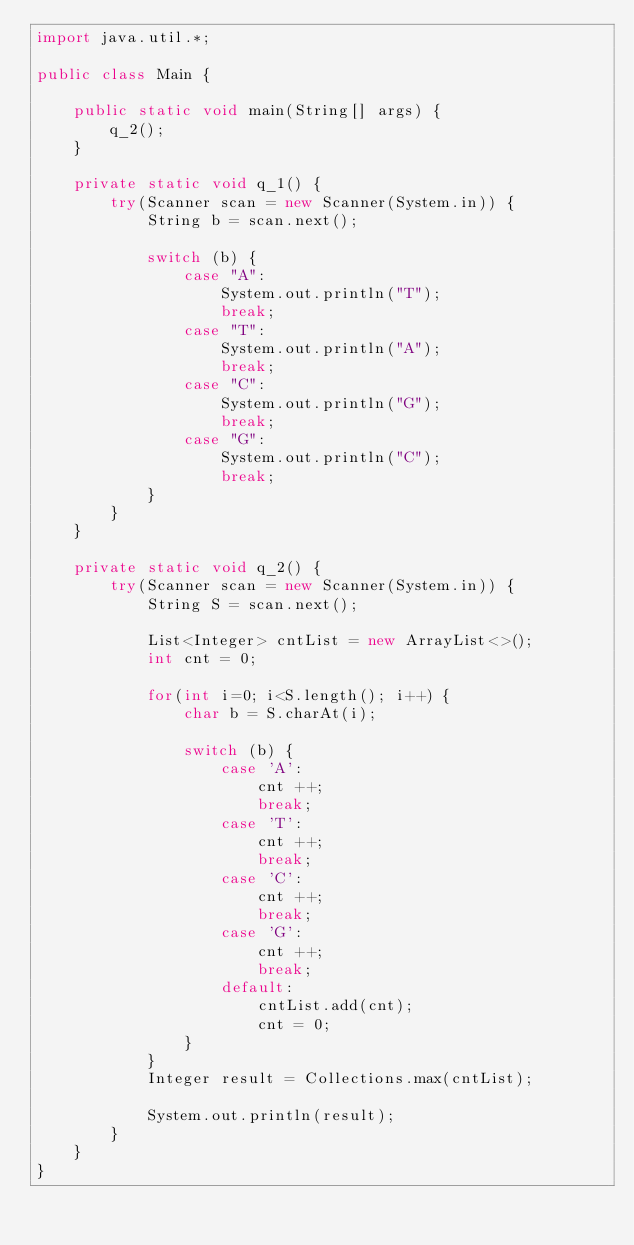<code> <loc_0><loc_0><loc_500><loc_500><_Java_>import java.util.*;

public class Main {

    public static void main(String[] args) {
        q_2();
    }

    private static void q_1() {
        try(Scanner scan = new Scanner(System.in)) {
            String b = scan.next();

            switch (b) {
                case "A":
                    System.out.println("T");
                    break;
                case "T":
                    System.out.println("A");
                    break;
                case "C":
                    System.out.println("G");
                    break;
                case "G":
                    System.out.println("C");
                    break;
            }
        }
    }

    private static void q_2() {
        try(Scanner scan = new Scanner(System.in)) {
            String S = scan.next();

            List<Integer> cntList = new ArrayList<>();
            int cnt = 0;

            for(int i=0; i<S.length(); i++) {
                char b = S.charAt(i);

                switch (b) {
                    case 'A':
                        cnt ++;
                        break;
                    case 'T':
                        cnt ++;
                        break;
                    case 'C':
                        cnt ++;
                        break;
                    case 'G':
                        cnt ++;
                        break;
                    default:
                        cntList.add(cnt);
                        cnt = 0;
                }
            }
            Integer result = Collections.max(cntList);

            System.out.println(result);
        }
    }
}
</code> 